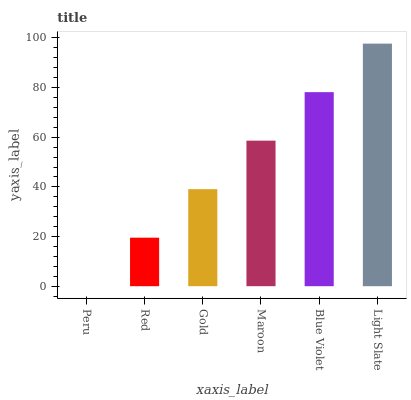Is Peru the minimum?
Answer yes or no. Yes. Is Light Slate the maximum?
Answer yes or no. Yes. Is Red the minimum?
Answer yes or no. No. Is Red the maximum?
Answer yes or no. No. Is Red greater than Peru?
Answer yes or no. Yes. Is Peru less than Red?
Answer yes or no. Yes. Is Peru greater than Red?
Answer yes or no. No. Is Red less than Peru?
Answer yes or no. No. Is Maroon the high median?
Answer yes or no. Yes. Is Gold the low median?
Answer yes or no. Yes. Is Blue Violet the high median?
Answer yes or no. No. Is Maroon the low median?
Answer yes or no. No. 